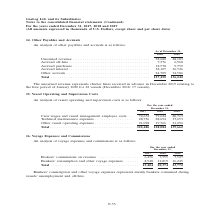According to Gaslog's financial document, What does bunkers’ consumption and other voyage expenses represent? Bunkers’ consumption and other voyage expenses represents mainly bunkers consumed during vessels’ unemployment and off-hire.. The document states: "Bunkers’ consumption and other voyage expenses represents mainly bunkers consumed during vessels’ unemployment and off-hire...." Also, In which year was the voyage expenses and commissions recorded for? The document contains multiple relevant values: 2017, 2018, 2019. From the document: "For the year ended December 31, 2017 2018 2019 For the year ended December 31, 2017 2018 2019 For the year ended December 31, 2017 2018 2019..." Also, What was the brokers' commissions on revenue in 2017? According to the financial document, 6,456 (in thousands). The relevant text states: "Brokers’ commissions on revenue . 6,456 7,555 7,527 Bunkers’ consumption and other voyage expenses . 8,948 12,819 16,245..." Additionally, In which year was the brokers' commissions on revenue the highest? According to the financial document, 2018. The relevant text states: "For the year ended December 31, 2017 2018 2019..." Also, can you calculate: What was the change in bunkers’ consumption and other voyage expenses from 2018 to 2019? Based on the calculation: 16,245 - 12,819 , the result is 3426 (in thousands). This is based on the information: "rs’ consumption and other voyage expenses . 8,948 12,819 16,245 sumption and other voyage expenses . 8,948 12,819 16,245..." The key data points involved are: 12,819, 16,245. Also, can you calculate: What was the percentage change in total voyage expenses and commissions from 2017 to 2018? To answer this question, I need to perform calculations using the financial data. The calculation is: (20,374 - 15,404)/15,404 , which equals 32.26 (percentage). This is based on the information: "Total . 15,404 20,374 23,772 Total . 15,404 20,374 23,772..." The key data points involved are: 15,404, 20,374. 